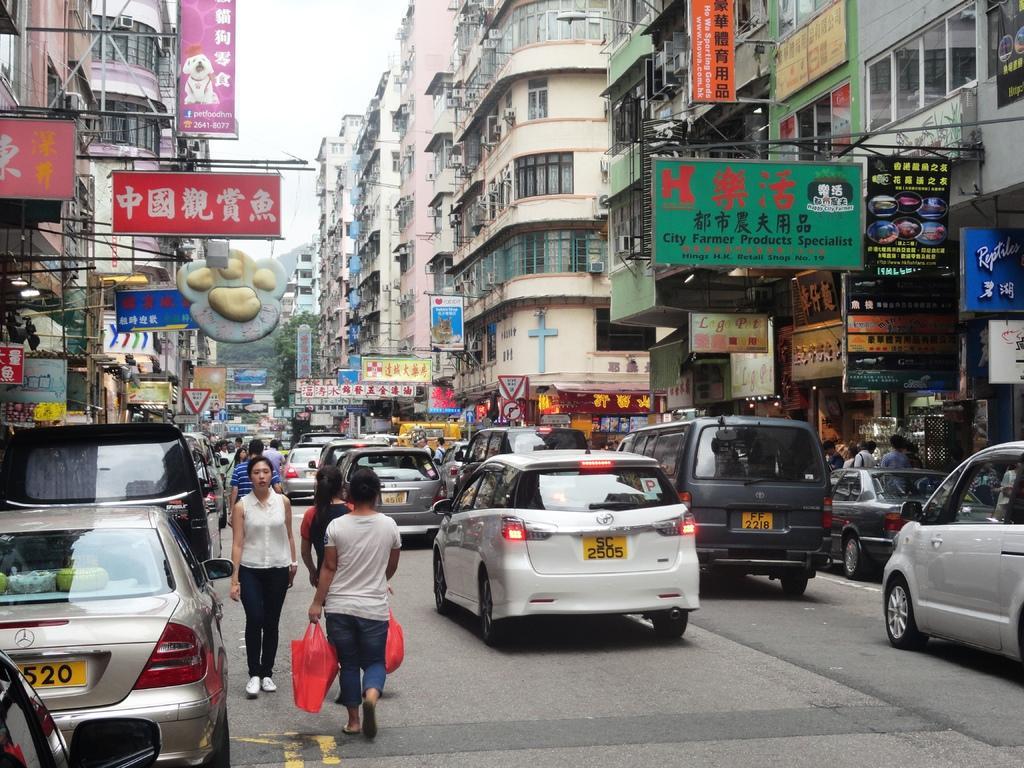Please provide a concise description of this image. This picture is clicked outside. In the center we can see the group of persons seems to be walking on the ground and we can see the group of cars and the buildings and we can see the text and some pictures on the boards. In the background we can see the sky, trees, vehicles, buildings and many other objects. In the foreground we can see a person holding a red color bag and walking on the ground. 